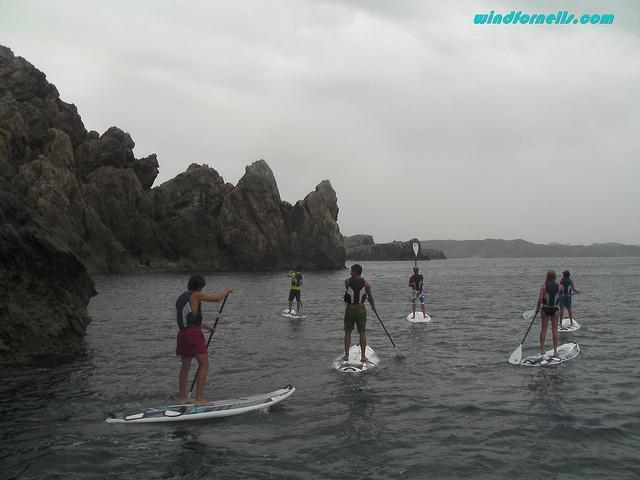What is required for this activity?
Choose the correct response and explain in the format: 'Answer: answer
Rationale: rationale.'
Options: Wind, ice, water, snow. Answer: water.
Rationale: They are paddle boarding on the ocean. 